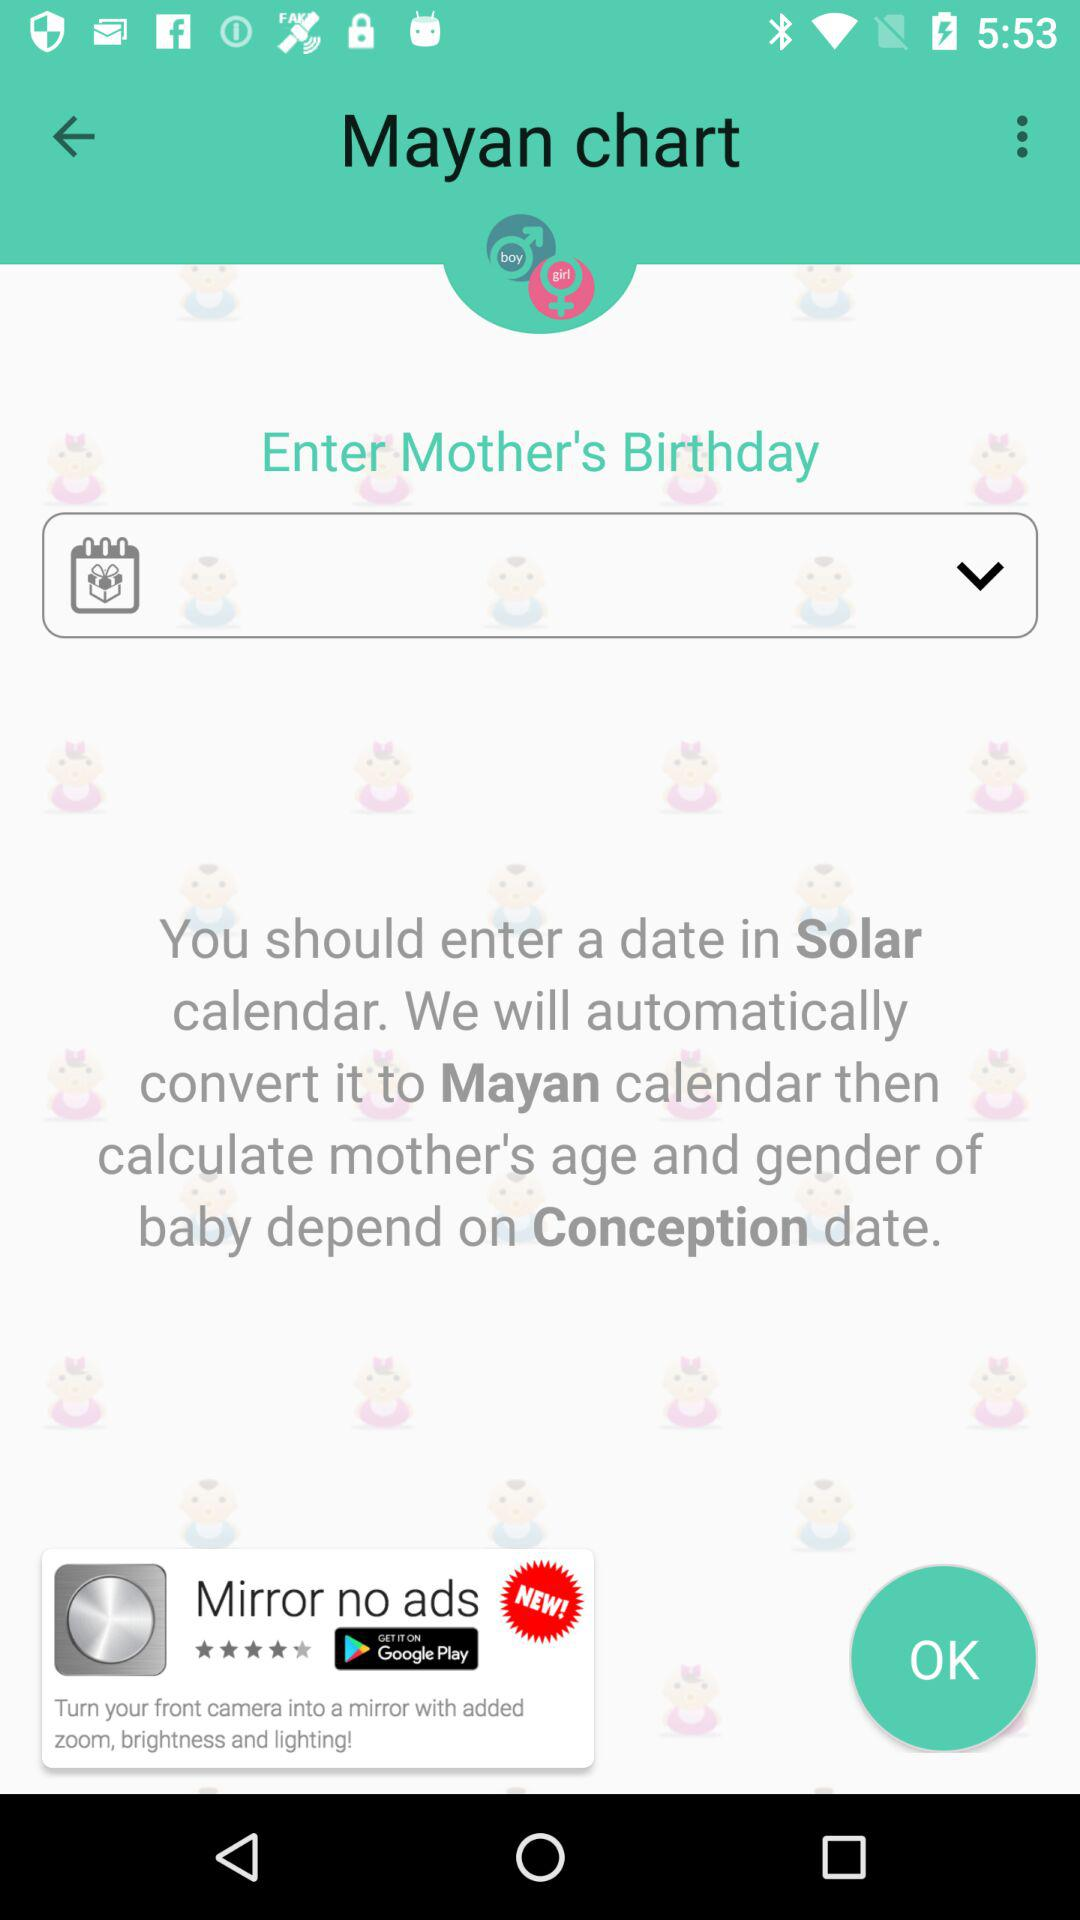What is the application name? The application name is "Baby Gender Predictor". 